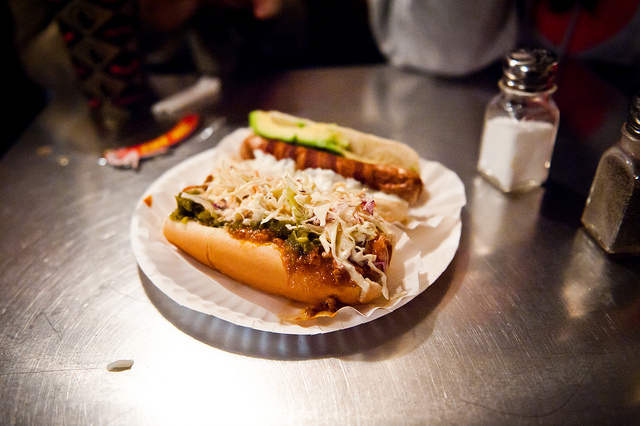<image>Are there any fried onions on the hot dogs? I am not sure. There might be fried onions on the hot dogs. Are there any fried onions on the hot dogs? There are no fried onions on the hot dogs. 